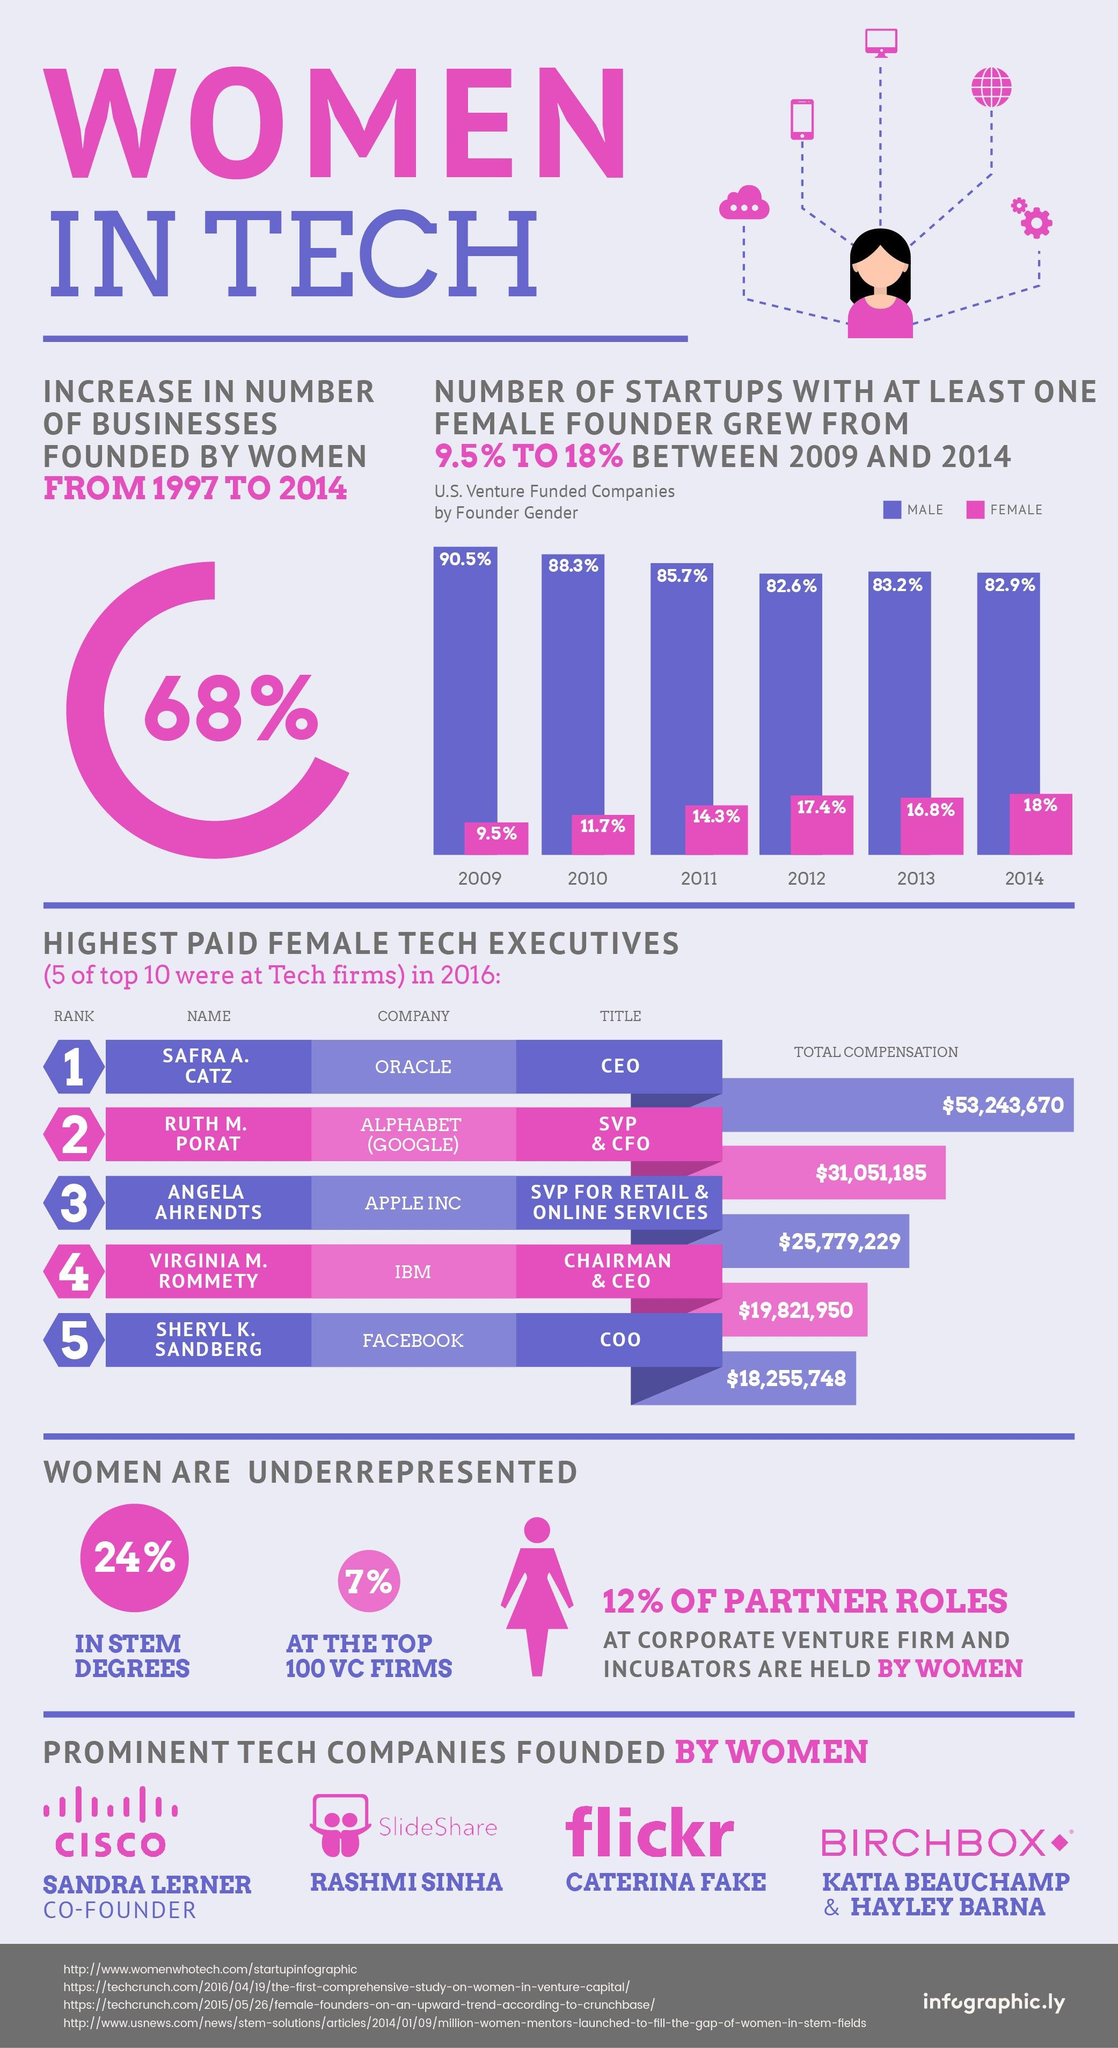Outline some significant characteristics in this image. Caterina Fake was the founder of Flickr. During the period between 2013 and 2014, the percentage drop in startups spearheaded by males was 0.3%. 